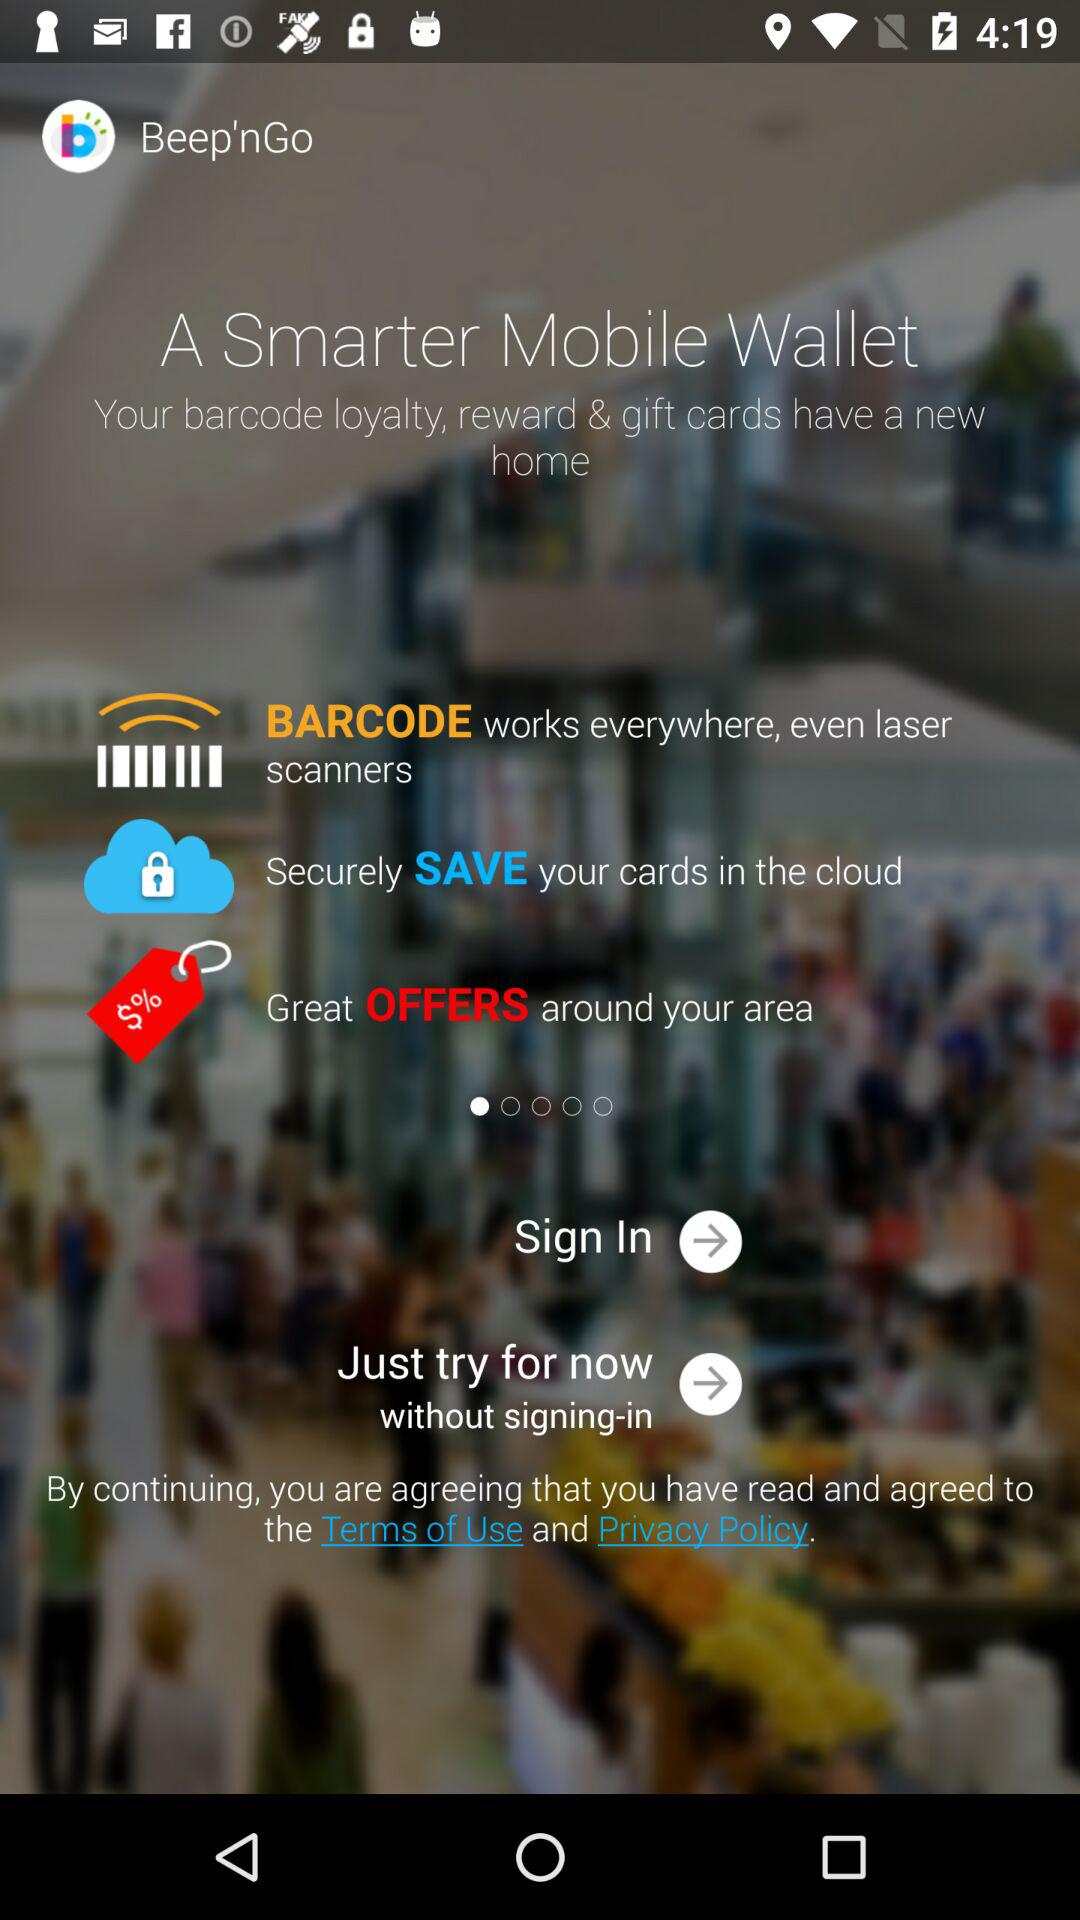What is the app name? The app name is "Beep'nGo". 